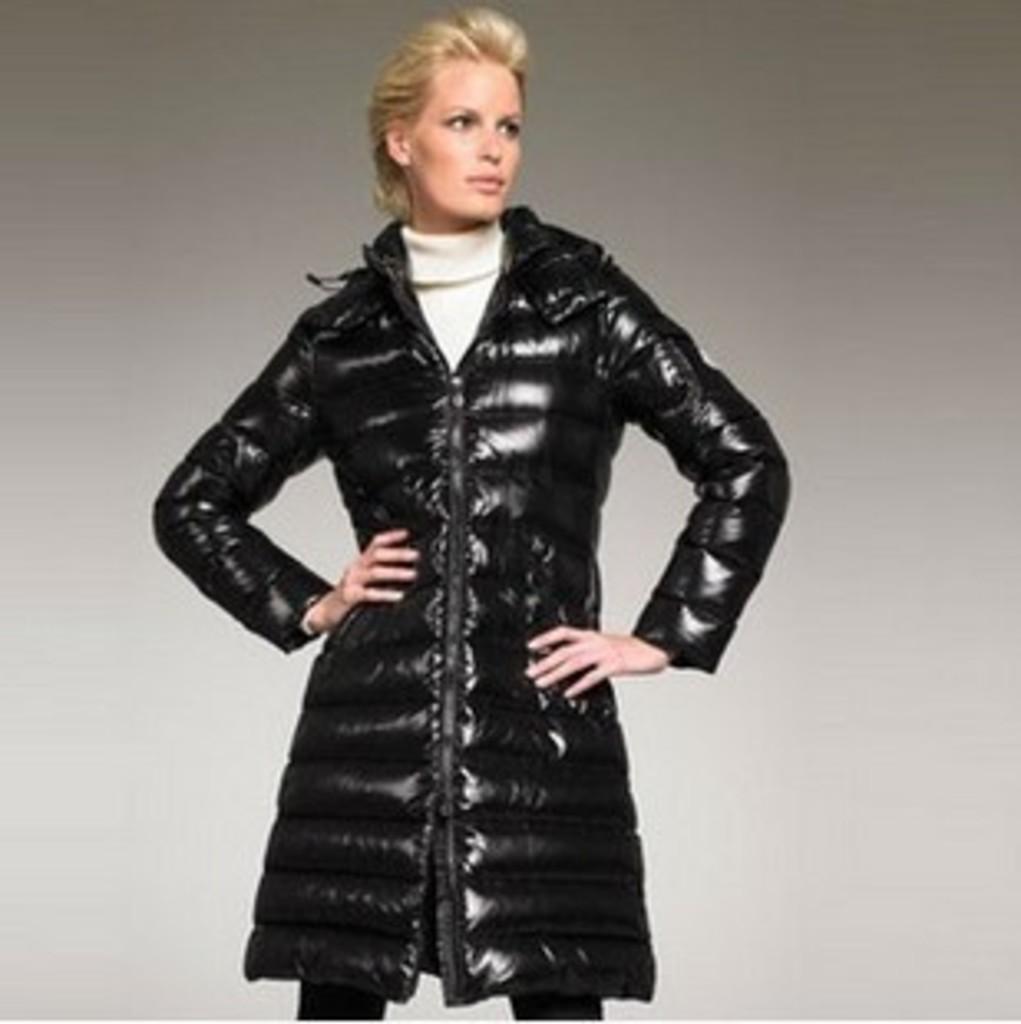Could you give a brief overview of what you see in this image? In this image we can see a person standing and wearing a black color jacket and posing for a photo. 